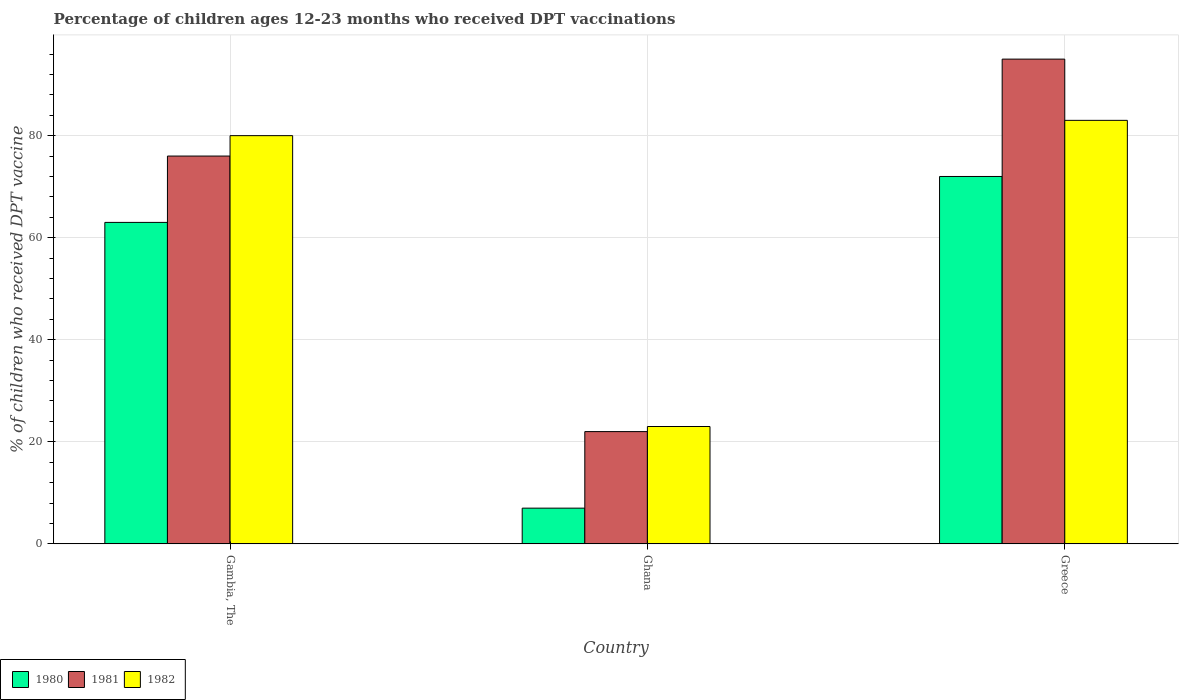How many different coloured bars are there?
Ensure brevity in your answer.  3. How many bars are there on the 2nd tick from the left?
Make the answer very short. 3. What is the label of the 3rd group of bars from the left?
Your response must be concise. Greece. What is the percentage of children who received DPT vaccination in 1981 in Greece?
Keep it short and to the point. 95. Across all countries, what is the minimum percentage of children who received DPT vaccination in 1981?
Offer a terse response. 22. What is the total percentage of children who received DPT vaccination in 1980 in the graph?
Keep it short and to the point. 142. What is the difference between the percentage of children who received DPT vaccination in 1981 in Gambia, The and that in Greece?
Your response must be concise. -19. What is the average percentage of children who received DPT vaccination in 1982 per country?
Provide a succinct answer. 62. What is the ratio of the percentage of children who received DPT vaccination in 1982 in Ghana to that in Greece?
Your response must be concise. 0.28. What is the difference between the highest and the second highest percentage of children who received DPT vaccination in 1982?
Your answer should be very brief. -3. What is the difference between the highest and the lowest percentage of children who received DPT vaccination in 1981?
Make the answer very short. 73. In how many countries, is the percentage of children who received DPT vaccination in 1981 greater than the average percentage of children who received DPT vaccination in 1981 taken over all countries?
Offer a terse response. 2. Is the sum of the percentage of children who received DPT vaccination in 1981 in Gambia, The and Greece greater than the maximum percentage of children who received DPT vaccination in 1980 across all countries?
Give a very brief answer. Yes. What does the 1st bar from the left in Ghana represents?
Give a very brief answer. 1980. What does the 2nd bar from the right in Gambia, The represents?
Ensure brevity in your answer.  1981. Is it the case that in every country, the sum of the percentage of children who received DPT vaccination in 1982 and percentage of children who received DPT vaccination in 1981 is greater than the percentage of children who received DPT vaccination in 1980?
Provide a succinct answer. Yes. Are all the bars in the graph horizontal?
Ensure brevity in your answer.  No. What is the difference between two consecutive major ticks on the Y-axis?
Keep it short and to the point. 20. Are the values on the major ticks of Y-axis written in scientific E-notation?
Give a very brief answer. No. Does the graph contain any zero values?
Make the answer very short. No. What is the title of the graph?
Your answer should be very brief. Percentage of children ages 12-23 months who received DPT vaccinations. Does "2002" appear as one of the legend labels in the graph?
Provide a succinct answer. No. What is the label or title of the X-axis?
Provide a short and direct response. Country. What is the label or title of the Y-axis?
Your answer should be compact. % of children who received DPT vaccine. What is the % of children who received DPT vaccine in 1981 in Gambia, The?
Your answer should be compact. 76. What is the % of children who received DPT vaccine of 1982 in Gambia, The?
Your answer should be very brief. 80. What is the % of children who received DPT vaccine in 1980 in Greece?
Offer a very short reply. 72. Across all countries, what is the maximum % of children who received DPT vaccine in 1980?
Make the answer very short. 72. Across all countries, what is the maximum % of children who received DPT vaccine in 1981?
Keep it short and to the point. 95. Across all countries, what is the maximum % of children who received DPT vaccine of 1982?
Ensure brevity in your answer.  83. Across all countries, what is the minimum % of children who received DPT vaccine in 1981?
Your response must be concise. 22. Across all countries, what is the minimum % of children who received DPT vaccine in 1982?
Provide a short and direct response. 23. What is the total % of children who received DPT vaccine in 1980 in the graph?
Give a very brief answer. 142. What is the total % of children who received DPT vaccine of 1981 in the graph?
Offer a terse response. 193. What is the total % of children who received DPT vaccine in 1982 in the graph?
Offer a very short reply. 186. What is the difference between the % of children who received DPT vaccine of 1980 in Gambia, The and that in Ghana?
Make the answer very short. 56. What is the difference between the % of children who received DPT vaccine of 1982 in Gambia, The and that in Ghana?
Keep it short and to the point. 57. What is the difference between the % of children who received DPT vaccine of 1980 in Gambia, The and that in Greece?
Keep it short and to the point. -9. What is the difference between the % of children who received DPT vaccine of 1981 in Gambia, The and that in Greece?
Ensure brevity in your answer.  -19. What is the difference between the % of children who received DPT vaccine of 1980 in Ghana and that in Greece?
Your answer should be compact. -65. What is the difference between the % of children who received DPT vaccine in 1981 in Ghana and that in Greece?
Provide a short and direct response. -73. What is the difference between the % of children who received DPT vaccine in 1982 in Ghana and that in Greece?
Give a very brief answer. -60. What is the difference between the % of children who received DPT vaccine in 1980 in Gambia, The and the % of children who received DPT vaccine in 1982 in Ghana?
Provide a short and direct response. 40. What is the difference between the % of children who received DPT vaccine in 1980 in Gambia, The and the % of children who received DPT vaccine in 1981 in Greece?
Give a very brief answer. -32. What is the difference between the % of children who received DPT vaccine of 1980 in Ghana and the % of children who received DPT vaccine of 1981 in Greece?
Provide a short and direct response. -88. What is the difference between the % of children who received DPT vaccine in 1980 in Ghana and the % of children who received DPT vaccine in 1982 in Greece?
Offer a very short reply. -76. What is the difference between the % of children who received DPT vaccine in 1981 in Ghana and the % of children who received DPT vaccine in 1982 in Greece?
Keep it short and to the point. -61. What is the average % of children who received DPT vaccine of 1980 per country?
Give a very brief answer. 47.33. What is the average % of children who received DPT vaccine in 1981 per country?
Make the answer very short. 64.33. What is the average % of children who received DPT vaccine in 1982 per country?
Provide a succinct answer. 62. What is the difference between the % of children who received DPT vaccine in 1980 and % of children who received DPT vaccine in 1981 in Gambia, The?
Provide a short and direct response. -13. What is the difference between the % of children who received DPT vaccine of 1980 and % of children who received DPT vaccine of 1982 in Ghana?
Offer a terse response. -16. What is the difference between the % of children who received DPT vaccine of 1980 and % of children who received DPT vaccine of 1981 in Greece?
Make the answer very short. -23. What is the difference between the % of children who received DPT vaccine in 1981 and % of children who received DPT vaccine in 1982 in Greece?
Provide a short and direct response. 12. What is the ratio of the % of children who received DPT vaccine of 1981 in Gambia, The to that in Ghana?
Provide a succinct answer. 3.45. What is the ratio of the % of children who received DPT vaccine in 1982 in Gambia, The to that in Ghana?
Your response must be concise. 3.48. What is the ratio of the % of children who received DPT vaccine in 1980 in Gambia, The to that in Greece?
Your answer should be compact. 0.88. What is the ratio of the % of children who received DPT vaccine in 1982 in Gambia, The to that in Greece?
Ensure brevity in your answer.  0.96. What is the ratio of the % of children who received DPT vaccine of 1980 in Ghana to that in Greece?
Make the answer very short. 0.1. What is the ratio of the % of children who received DPT vaccine of 1981 in Ghana to that in Greece?
Make the answer very short. 0.23. What is the ratio of the % of children who received DPT vaccine in 1982 in Ghana to that in Greece?
Offer a very short reply. 0.28. What is the difference between the highest and the second highest % of children who received DPT vaccine of 1980?
Provide a succinct answer. 9. What is the difference between the highest and the second highest % of children who received DPT vaccine in 1981?
Your answer should be compact. 19. 